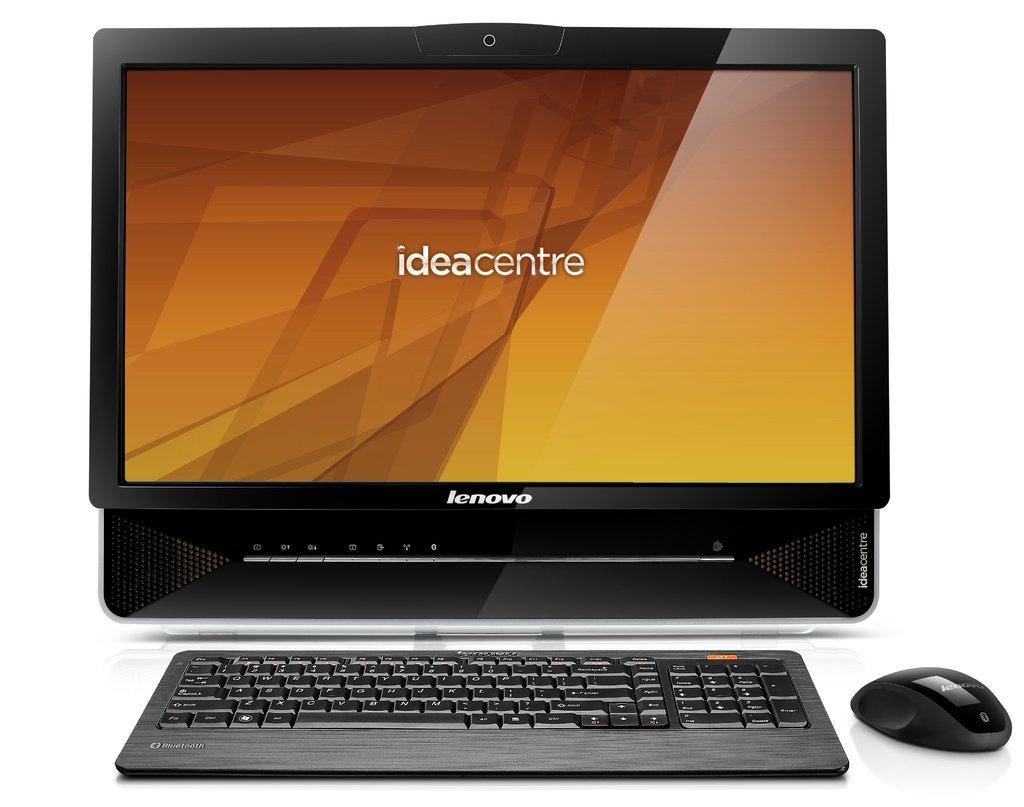What brand of computer is this?
Ensure brevity in your answer.  Lenovo. What does it say in the screen?
Your response must be concise. Ideacentre. 